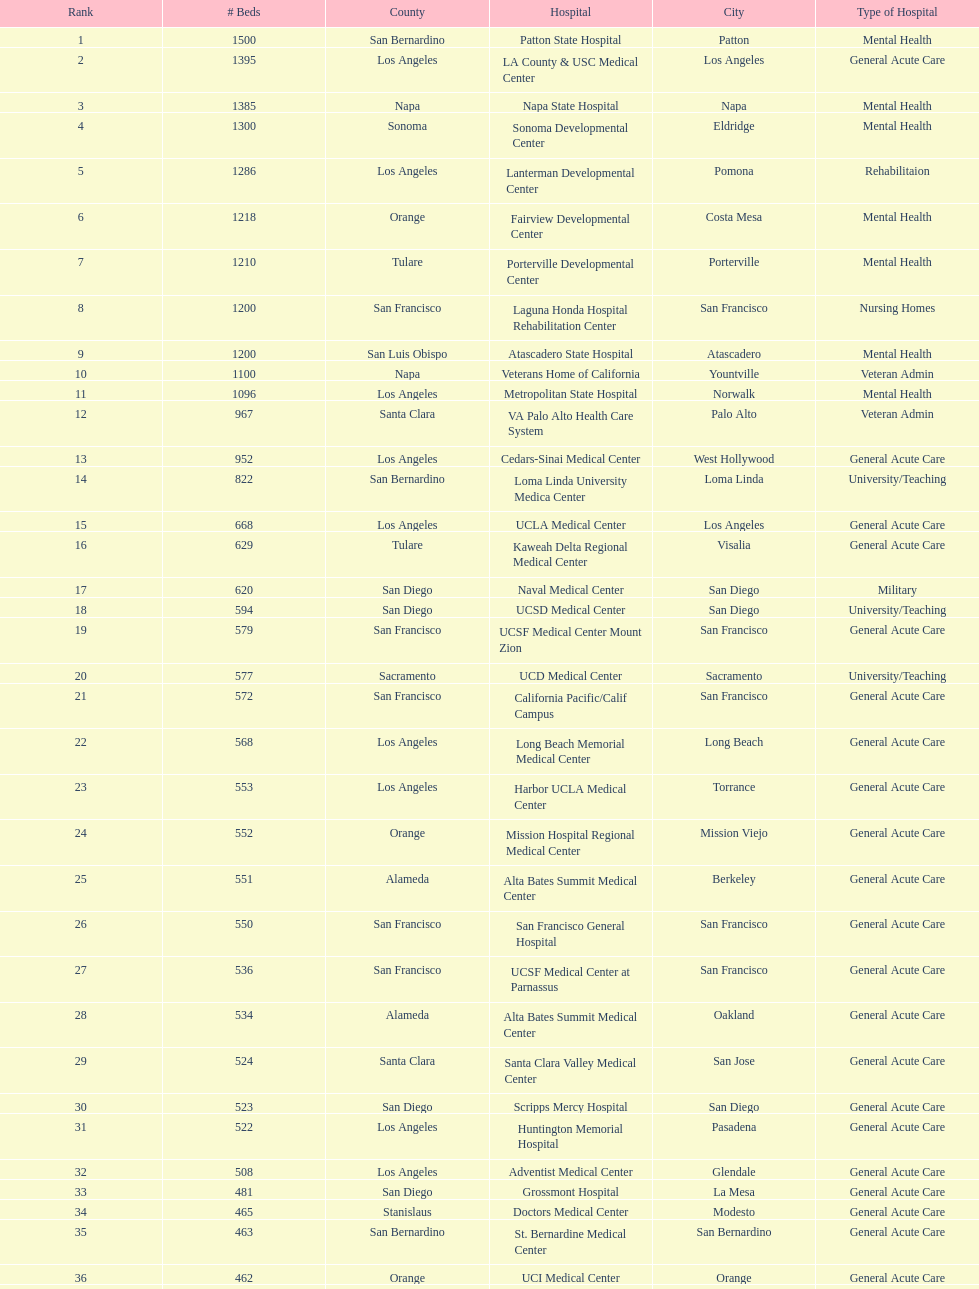What two hospitals holding consecutive rankings of 8 and 9 respectively, both provide 1200 hospital beds? Laguna Honda Hospital Rehabilitation Center, Atascadero State Hospital. 